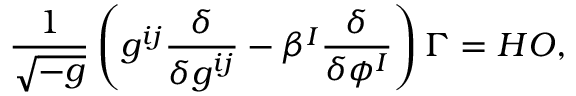<formula> <loc_0><loc_0><loc_500><loc_500>\frac { 1 } { \sqrt { - g } } \left ( g ^ { i j } { \frac { \delta } { \delta g ^ { i j } } } - \beta ^ { I } \frac { \delta } { \delta \phi ^ { I } } \right ) \Gamma = H O ,</formula> 